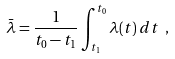<formula> <loc_0><loc_0><loc_500><loc_500>\bar { \lambda } = \frac { 1 } { t _ { 0 } - t _ { 1 } } \int _ { t _ { 1 } } ^ { t _ { 0 } } \lambda ( t ) \, d t \ ,</formula> 